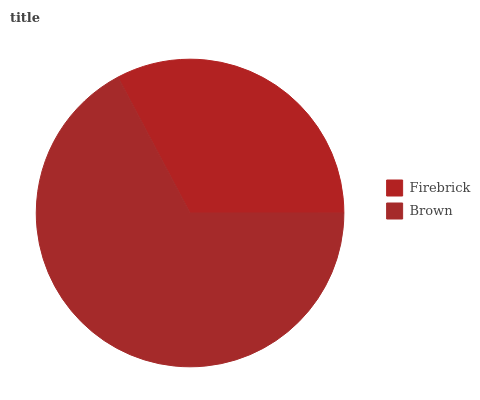Is Firebrick the minimum?
Answer yes or no. Yes. Is Brown the maximum?
Answer yes or no. Yes. Is Brown the minimum?
Answer yes or no. No. Is Brown greater than Firebrick?
Answer yes or no. Yes. Is Firebrick less than Brown?
Answer yes or no. Yes. Is Firebrick greater than Brown?
Answer yes or no. No. Is Brown less than Firebrick?
Answer yes or no. No. Is Brown the high median?
Answer yes or no. Yes. Is Firebrick the low median?
Answer yes or no. Yes. Is Firebrick the high median?
Answer yes or no. No. Is Brown the low median?
Answer yes or no. No. 